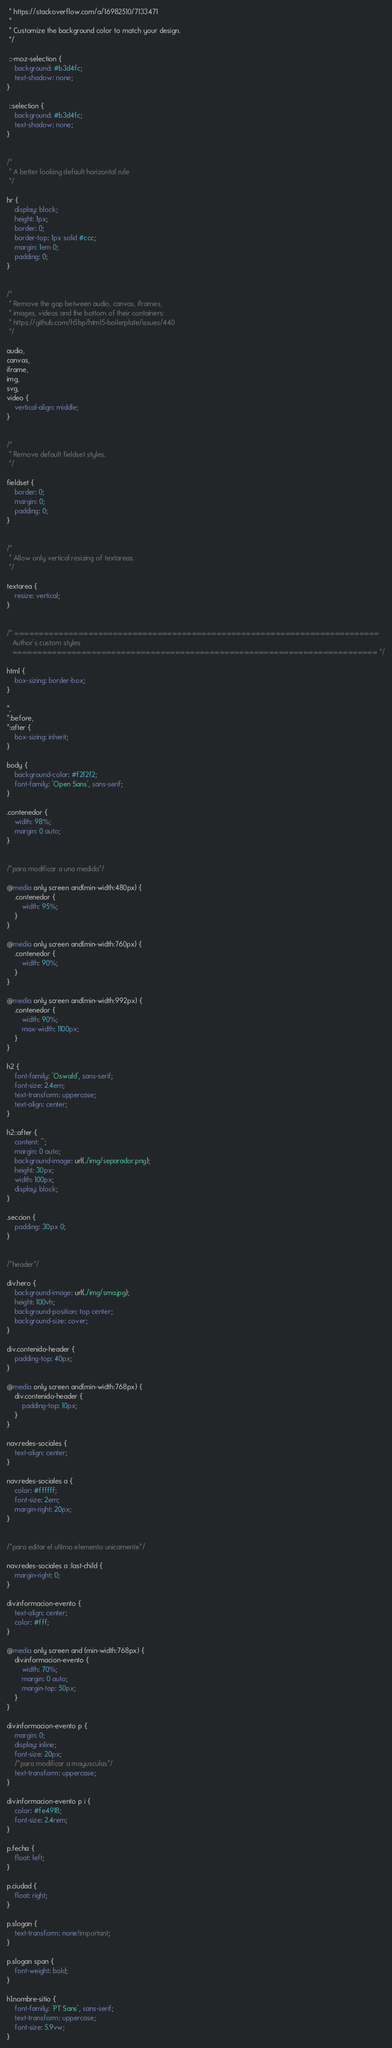Convert code to text. <code><loc_0><loc_0><loc_500><loc_500><_CSS_> * https://stackoverflow.com/a/16982510/7133471
 *
 * Customize the background color to match your design.
 */

 ::-moz-selection {
    background: #b3d4fc;
    text-shadow: none;
}

 ::selection {
    background: #b3d4fc;
    text-shadow: none;
}


/*
 * A better looking default horizontal rule
 */

hr {
    display: block;
    height: 1px;
    border: 0;
    border-top: 1px solid #ccc;
    margin: 1em 0;
    padding: 0;
}


/*
 * Remove the gap between audio, canvas, iframes,
 * images, videos and the bottom of their containers:
 * https://github.com/h5bp/html5-boilerplate/issues/440
 */

audio,
canvas,
iframe,
img,
svg,
video {
    vertical-align: middle;
}


/*
 * Remove default fieldset styles.
 */

fieldset {
    border: 0;
    margin: 0;
    padding: 0;
}


/*
 * Allow only vertical resizing of textareas.
 */

textarea {
    resize: vertical;
}


/* ==========================================================================
   Author's custom styles
   ========================================================================== */

html {
    box-sizing: border-box;
}

*,
*:before,
*:after {
    box-sizing: inherit;
}

body {
    background-color: #f2f2f2;
    font-family: 'Open Sans', sans-serif;
}

.contenedor {
    width: 98%;
    margin: 0 auto;
}


/*para modificar a una medida*/

@media only screen and(min-width:480px) {
    .contenedor {
        width: 95%;
    }
}

@media only screen and(min-width:760px) {
    .contenedor {
        width: 90%;
    }
}

@media only screen and(min-width:992px) {
    .contenedor {
        width: 90%;
        max-width: 1100px;
    }
}

h2 {
    font-family: 'Oswald', sans-serif;
    font-size: 2.4em;
    text-transform: uppercase;
    text-align: center;
}

h2::after {
    content: '';
    margin: 0 auto;
    background-image: url(../img/separador.png);
    height: 30px;
    width: 100px;
    display: block;
}

.seccion {
    padding: 30px 0;
}


/*header*/

div.hero {
    background-image: url(../img/sma.jpg);
    height: 100vh;
    background-position: top center;
    background-size: cover;
}

div.contenido-header {
    padding-top: 40px;
}

@media only screen and(min-width:768px) {
    div.contenido-header {
        padding-top: 10px;
    }
}

nav.redes-sociales {
    text-align: center;
}

nav.redes-sociales a {
    color: #ffffff;
    font-size: 2em;
    margin-right: 20px;
}


/*para editar el ultimo elemento unicamente*/

nav.redes-sociales a :last-child {
    margin-right: 0;
}

div.informacion-evento {
    text-align: center;
    color: #fff;
}

@media only screen and (min-width:768px) {
    div.informacion-evento {
        width: 70%;
        margin: 0 auto;
        margin-top: 50px;
    }
}

div.informacion-evento p {
    margin: 0;
    display: inline;
    font-size: 20px;
    /*para modificar a mayusculas*/
    text-transform: uppercase;
}

div.informacion-evento p i {
    color: #fe4918;
    font-size: 2.4rem;
}

p.fecha {
    float: left;
}

p.ciudad {
    float: right;
}

p.slogan {
    text-transform: none!important;
}

p.slogan span {
    font-weight: bold;
}

h1.nombre-sitio {
    font-family: 'PT Sans', sans-serif;
    text-transform: uppercase;
    font-size: 5.9vw;
}
</code> 